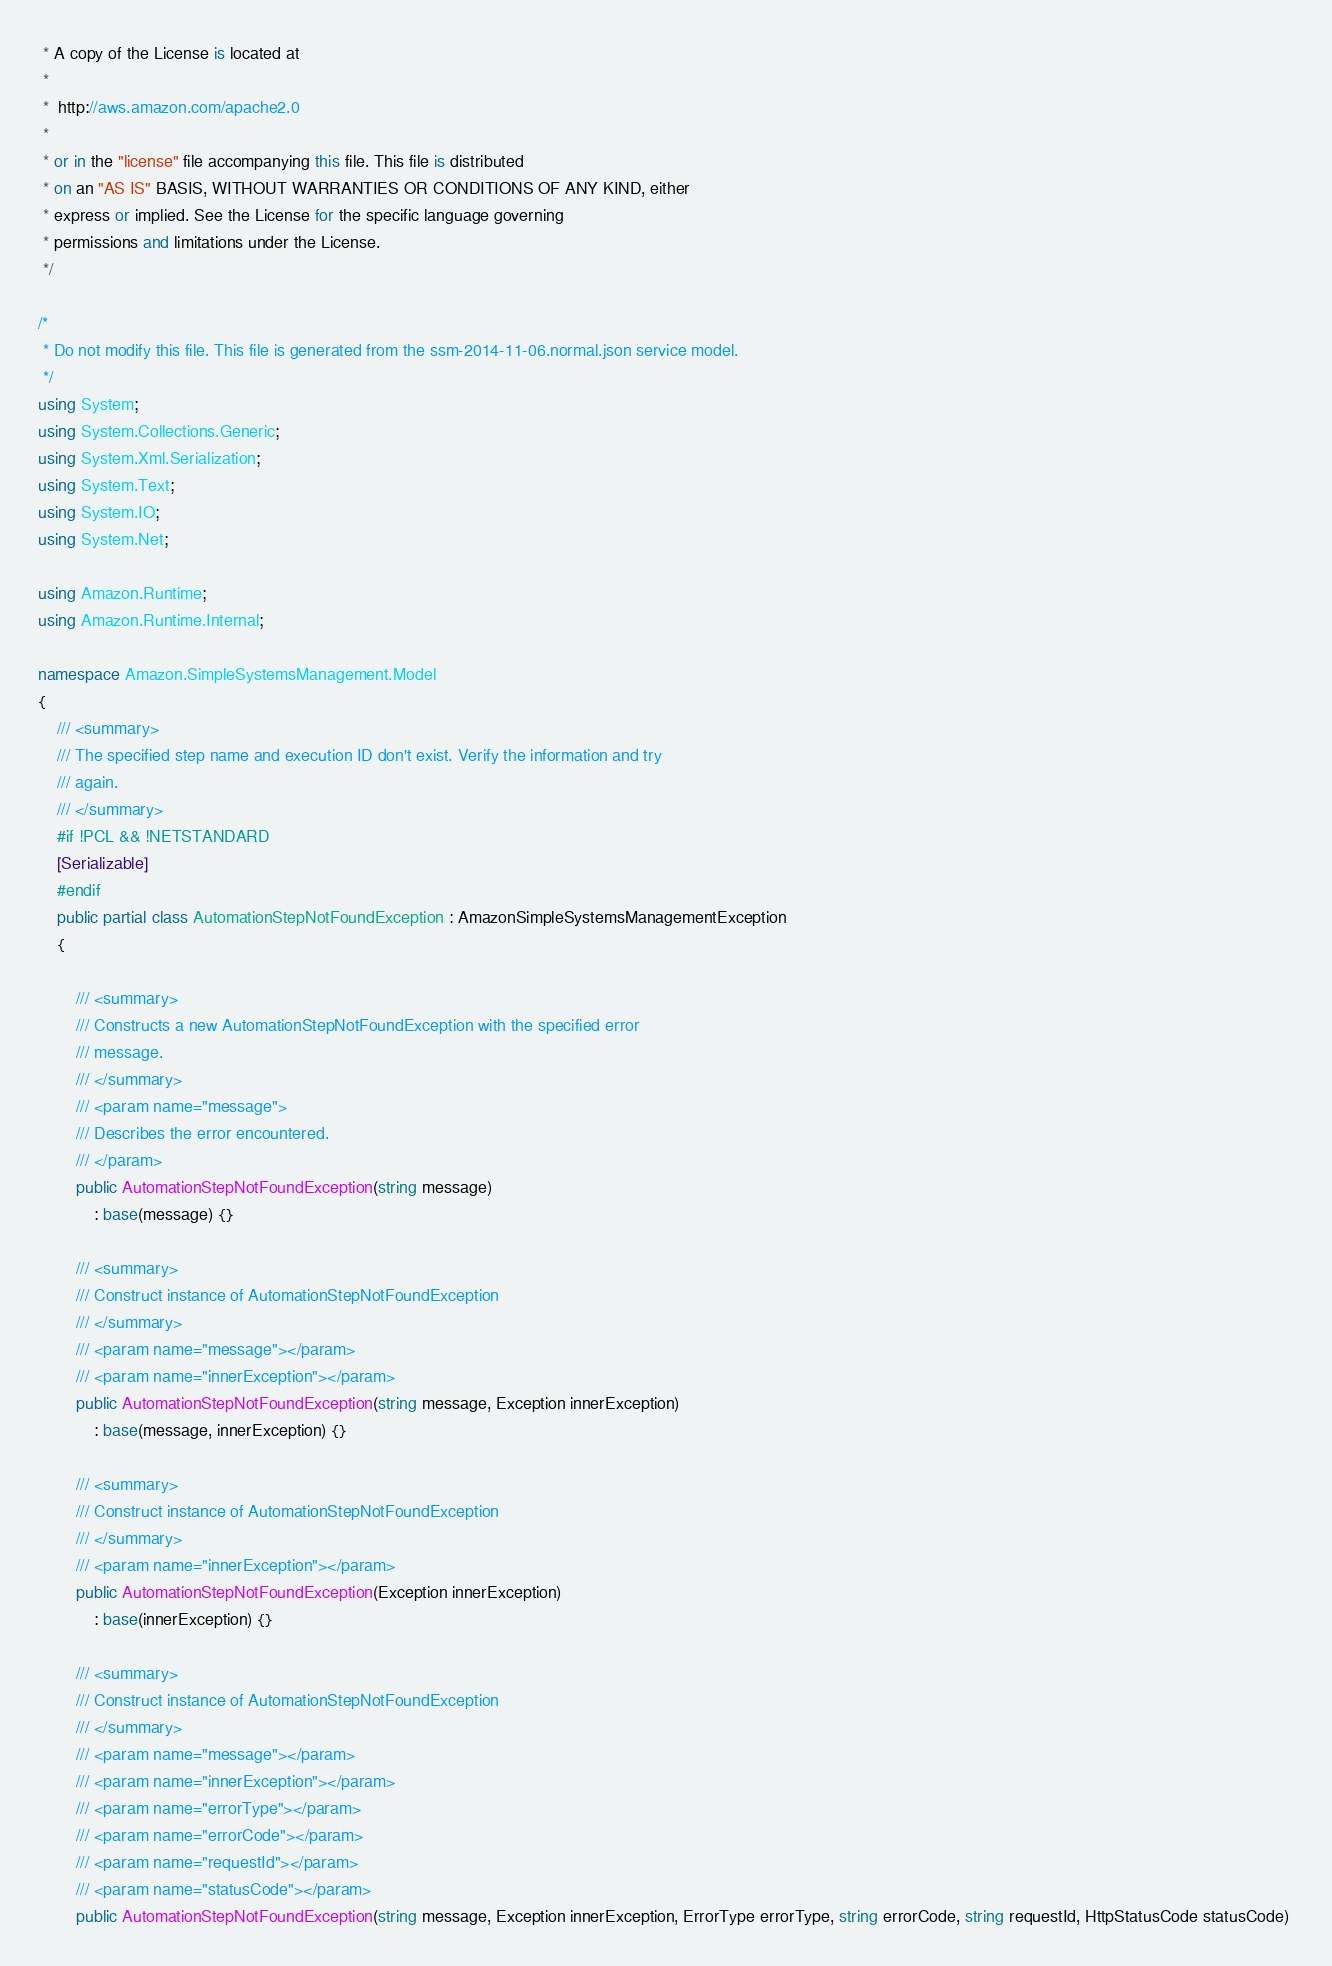<code> <loc_0><loc_0><loc_500><loc_500><_C#_> * A copy of the License is located at
 * 
 *  http://aws.amazon.com/apache2.0
 * 
 * or in the "license" file accompanying this file. This file is distributed
 * on an "AS IS" BASIS, WITHOUT WARRANTIES OR CONDITIONS OF ANY KIND, either
 * express or implied. See the License for the specific language governing
 * permissions and limitations under the License.
 */

/*
 * Do not modify this file. This file is generated from the ssm-2014-11-06.normal.json service model.
 */
using System;
using System.Collections.Generic;
using System.Xml.Serialization;
using System.Text;
using System.IO;
using System.Net;

using Amazon.Runtime;
using Amazon.Runtime.Internal;

namespace Amazon.SimpleSystemsManagement.Model
{
    /// <summary>
    /// The specified step name and execution ID don't exist. Verify the information and try
    /// again.
    /// </summary>
    #if !PCL && !NETSTANDARD
    [Serializable]
    #endif
    public partial class AutomationStepNotFoundException : AmazonSimpleSystemsManagementException
    {

        /// <summary>
        /// Constructs a new AutomationStepNotFoundException with the specified error
        /// message.
        /// </summary>
        /// <param name="message">
        /// Describes the error encountered.
        /// </param>
        public AutomationStepNotFoundException(string message) 
            : base(message) {}

        /// <summary>
        /// Construct instance of AutomationStepNotFoundException
        /// </summary>
        /// <param name="message"></param>
        /// <param name="innerException"></param>
        public AutomationStepNotFoundException(string message, Exception innerException) 
            : base(message, innerException) {}

        /// <summary>
        /// Construct instance of AutomationStepNotFoundException
        /// </summary>
        /// <param name="innerException"></param>
        public AutomationStepNotFoundException(Exception innerException) 
            : base(innerException) {}

        /// <summary>
        /// Construct instance of AutomationStepNotFoundException
        /// </summary>
        /// <param name="message"></param>
        /// <param name="innerException"></param>
        /// <param name="errorType"></param>
        /// <param name="errorCode"></param>
        /// <param name="requestId"></param>
        /// <param name="statusCode"></param>
        public AutomationStepNotFoundException(string message, Exception innerException, ErrorType errorType, string errorCode, string requestId, HttpStatusCode statusCode) </code> 